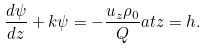Convert formula to latex. <formula><loc_0><loc_0><loc_500><loc_500>\frac { d \psi } { d z } + k \psi = - \frac { u _ { z } \rho _ { 0 } } { Q } a t z = h .</formula> 